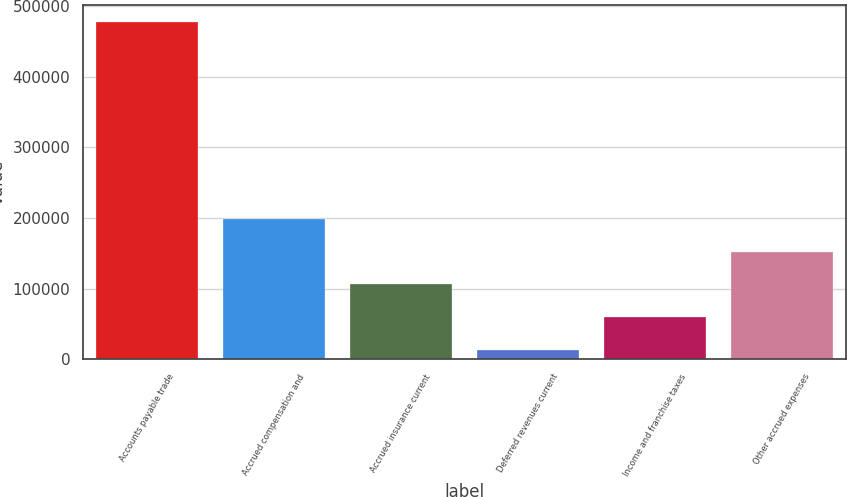Convert chart to OTSL. <chart><loc_0><loc_0><loc_500><loc_500><bar_chart><fcel>Accounts payable trade<fcel>Accrued compensation and<fcel>Accrued insurance current<fcel>Deferred revenues current<fcel>Income and franchise taxes<fcel>Other accrued expenses<nl><fcel>477370<fcel>198797<fcel>105940<fcel>13082<fcel>59510.8<fcel>152368<nl></chart> 